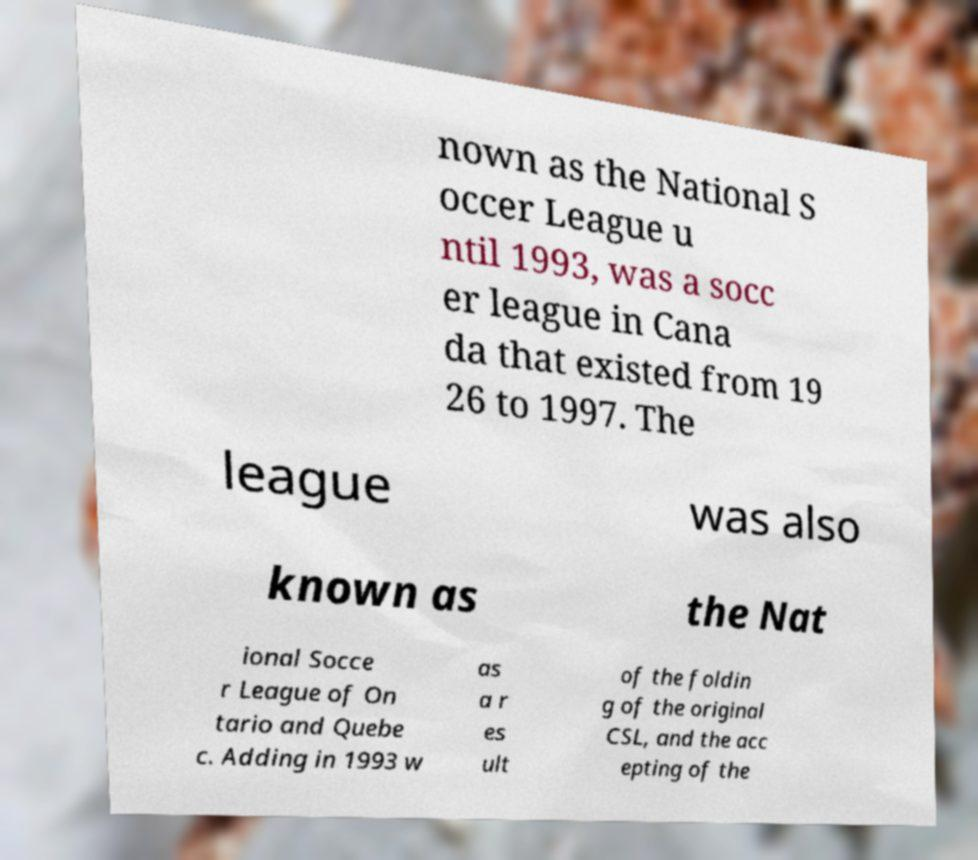Could you extract and type out the text from this image? nown as the National S occer League u ntil 1993, was a socc er league in Cana da that existed from 19 26 to 1997. The league was also known as the Nat ional Socce r League of On tario and Quebe c. Adding in 1993 w as a r es ult of the foldin g of the original CSL, and the acc epting of the 